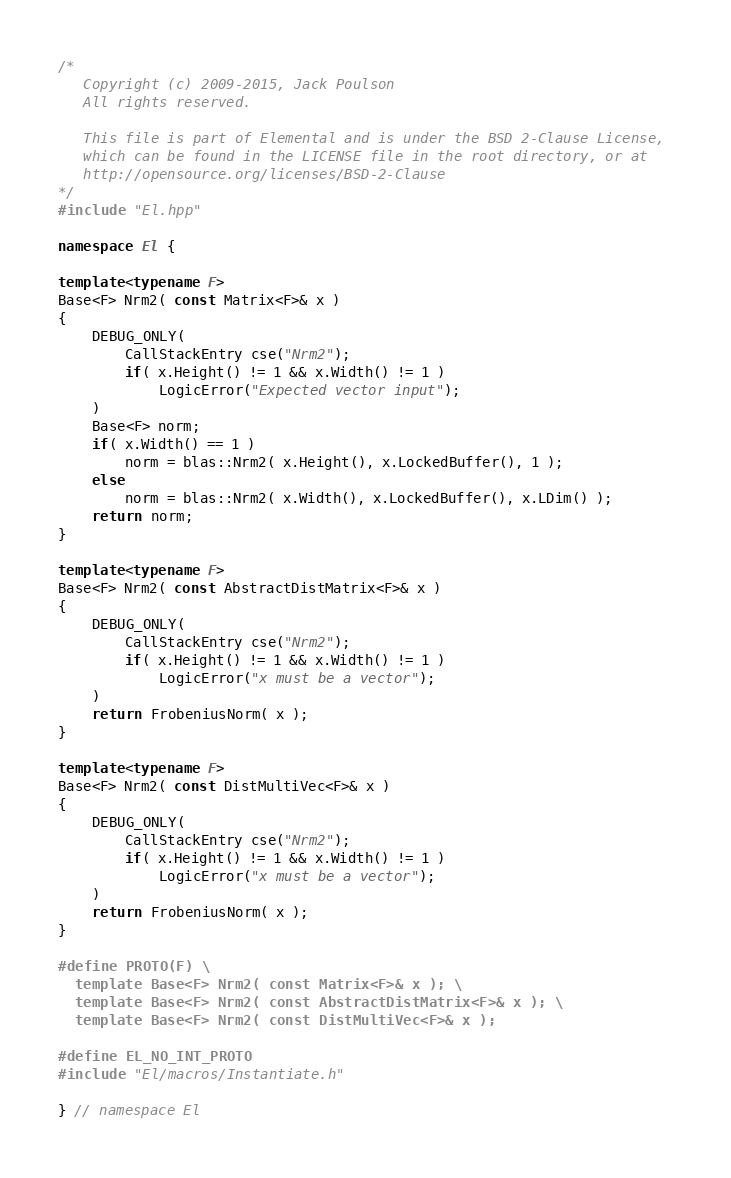<code> <loc_0><loc_0><loc_500><loc_500><_C++_>/*
   Copyright (c) 2009-2015, Jack Poulson
   All rights reserved.

   This file is part of Elemental and is under the BSD 2-Clause License, 
   which can be found in the LICENSE file in the root directory, or at 
   http://opensource.org/licenses/BSD-2-Clause
*/
#include "El.hpp"

namespace El {

template<typename F>
Base<F> Nrm2( const Matrix<F>& x )
{
    DEBUG_ONLY(
        CallStackEntry cse("Nrm2");
        if( x.Height() != 1 && x.Width() != 1 )
            LogicError("Expected vector input");
    )
    Base<F> norm;
    if( x.Width() == 1 )
        norm = blas::Nrm2( x.Height(), x.LockedBuffer(), 1 );
    else
        norm = blas::Nrm2( x.Width(), x.LockedBuffer(), x.LDim() );
    return norm;
}

template<typename F>
Base<F> Nrm2( const AbstractDistMatrix<F>& x )
{
    DEBUG_ONLY(
        CallStackEntry cse("Nrm2");
        if( x.Height() != 1 && x.Width() != 1 )
            LogicError("x must be a vector");
    )
    return FrobeniusNorm( x );
}

template<typename F>
Base<F> Nrm2( const DistMultiVec<F>& x )
{
    DEBUG_ONLY(
        CallStackEntry cse("Nrm2");
        if( x.Height() != 1 && x.Width() != 1 )
            LogicError("x must be a vector");
    )
    return FrobeniusNorm( x );
}

#define PROTO(F) \
  template Base<F> Nrm2( const Matrix<F>& x ); \
  template Base<F> Nrm2( const AbstractDistMatrix<F>& x ); \
  template Base<F> Nrm2( const DistMultiVec<F>& x );

#define EL_NO_INT_PROTO
#include "El/macros/Instantiate.h"

} // namespace El
</code> 